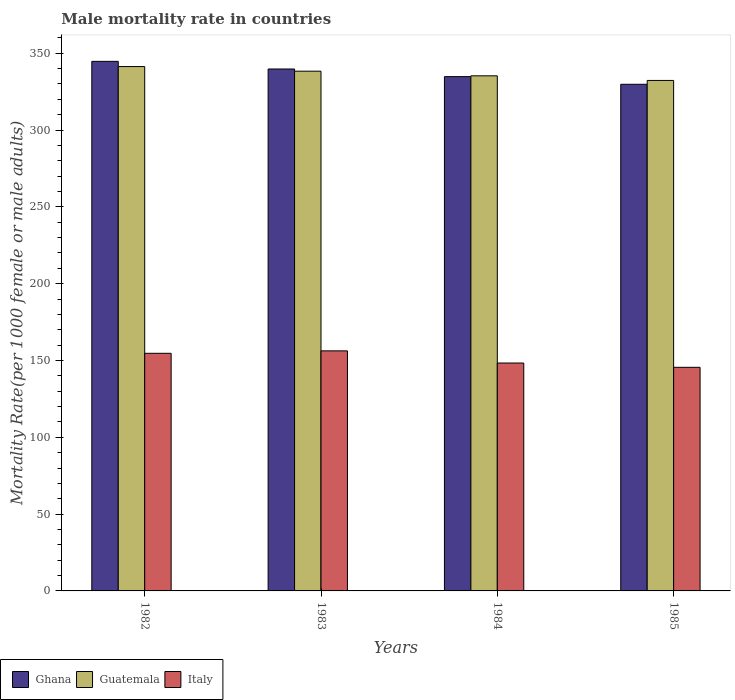Are the number of bars on each tick of the X-axis equal?
Ensure brevity in your answer.  Yes. How many bars are there on the 4th tick from the right?
Make the answer very short. 3. What is the label of the 3rd group of bars from the left?
Make the answer very short. 1984. In how many cases, is the number of bars for a given year not equal to the number of legend labels?
Your answer should be very brief. 0. What is the male mortality rate in Ghana in 1982?
Provide a short and direct response. 344.7. Across all years, what is the maximum male mortality rate in Ghana?
Provide a succinct answer. 344.7. Across all years, what is the minimum male mortality rate in Guatemala?
Provide a succinct answer. 332.27. What is the total male mortality rate in Guatemala in the graph?
Offer a very short reply. 1347.18. What is the difference between the male mortality rate in Italy in 1982 and that in 1985?
Ensure brevity in your answer.  9.12. What is the difference between the male mortality rate in Italy in 1982 and the male mortality rate in Guatemala in 1983?
Offer a terse response. -183.63. What is the average male mortality rate in Ghana per year?
Ensure brevity in your answer.  337.24. In the year 1983, what is the difference between the male mortality rate in Italy and male mortality rate in Ghana?
Give a very brief answer. -183.47. In how many years, is the male mortality rate in Italy greater than 270?
Offer a terse response. 0. What is the ratio of the male mortality rate in Italy in 1983 to that in 1985?
Give a very brief answer. 1.07. Is the difference between the male mortality rate in Italy in 1982 and 1984 greater than the difference between the male mortality rate in Ghana in 1982 and 1984?
Ensure brevity in your answer.  No. What is the difference between the highest and the second highest male mortality rate in Italy?
Your response must be concise. 1.58. What is the difference between the highest and the lowest male mortality rate in Ghana?
Give a very brief answer. 14.93. In how many years, is the male mortality rate in Ghana greater than the average male mortality rate in Ghana taken over all years?
Offer a terse response. 2. What does the 2nd bar from the left in 1985 represents?
Offer a terse response. Guatemala. What does the 1st bar from the right in 1983 represents?
Offer a terse response. Italy. Is it the case that in every year, the sum of the male mortality rate in Guatemala and male mortality rate in Ghana is greater than the male mortality rate in Italy?
Offer a terse response. Yes. How many bars are there?
Your answer should be very brief. 12. Are all the bars in the graph horizontal?
Provide a short and direct response. No. How many years are there in the graph?
Make the answer very short. 4. How many legend labels are there?
Ensure brevity in your answer.  3. How are the legend labels stacked?
Provide a short and direct response. Horizontal. What is the title of the graph?
Ensure brevity in your answer.  Male mortality rate in countries. Does "South Africa" appear as one of the legend labels in the graph?
Keep it short and to the point. No. What is the label or title of the X-axis?
Your response must be concise. Years. What is the label or title of the Y-axis?
Make the answer very short. Mortality Rate(per 1000 female or male adults). What is the Mortality Rate(per 1000 female or male adults) of Ghana in 1982?
Your answer should be very brief. 344.7. What is the Mortality Rate(per 1000 female or male adults) in Guatemala in 1982?
Provide a short and direct response. 341.32. What is the Mortality Rate(per 1000 female or male adults) in Italy in 1982?
Offer a very short reply. 154.67. What is the Mortality Rate(per 1000 female or male adults) in Ghana in 1983?
Provide a short and direct response. 339.73. What is the Mortality Rate(per 1000 female or male adults) in Guatemala in 1983?
Provide a succinct answer. 338.3. What is the Mortality Rate(per 1000 female or male adults) in Italy in 1983?
Offer a terse response. 156.25. What is the Mortality Rate(per 1000 female or male adults) of Ghana in 1984?
Ensure brevity in your answer.  334.75. What is the Mortality Rate(per 1000 female or male adults) of Guatemala in 1984?
Provide a succinct answer. 335.29. What is the Mortality Rate(per 1000 female or male adults) in Italy in 1984?
Your answer should be compact. 148.34. What is the Mortality Rate(per 1000 female or male adults) in Ghana in 1985?
Offer a very short reply. 329.77. What is the Mortality Rate(per 1000 female or male adults) of Guatemala in 1985?
Your answer should be very brief. 332.27. What is the Mortality Rate(per 1000 female or male adults) in Italy in 1985?
Provide a succinct answer. 145.55. Across all years, what is the maximum Mortality Rate(per 1000 female or male adults) of Ghana?
Your response must be concise. 344.7. Across all years, what is the maximum Mortality Rate(per 1000 female or male adults) in Guatemala?
Your answer should be very brief. 341.32. Across all years, what is the maximum Mortality Rate(per 1000 female or male adults) in Italy?
Provide a succinct answer. 156.25. Across all years, what is the minimum Mortality Rate(per 1000 female or male adults) in Ghana?
Provide a short and direct response. 329.77. Across all years, what is the minimum Mortality Rate(per 1000 female or male adults) in Guatemala?
Provide a short and direct response. 332.27. Across all years, what is the minimum Mortality Rate(per 1000 female or male adults) of Italy?
Offer a very short reply. 145.55. What is the total Mortality Rate(per 1000 female or male adults) of Ghana in the graph?
Make the answer very short. 1348.95. What is the total Mortality Rate(per 1000 female or male adults) of Guatemala in the graph?
Your answer should be very brief. 1347.18. What is the total Mortality Rate(per 1000 female or male adults) of Italy in the graph?
Give a very brief answer. 604.82. What is the difference between the Mortality Rate(per 1000 female or male adults) in Ghana in 1982 and that in 1983?
Offer a very short reply. 4.97. What is the difference between the Mortality Rate(per 1000 female or male adults) in Guatemala in 1982 and that in 1983?
Ensure brevity in your answer.  3.01. What is the difference between the Mortality Rate(per 1000 female or male adults) of Italy in 1982 and that in 1983?
Provide a short and direct response. -1.58. What is the difference between the Mortality Rate(per 1000 female or male adults) in Ghana in 1982 and that in 1984?
Make the answer very short. 9.95. What is the difference between the Mortality Rate(per 1000 female or male adults) in Guatemala in 1982 and that in 1984?
Give a very brief answer. 6.03. What is the difference between the Mortality Rate(per 1000 female or male adults) in Italy in 1982 and that in 1984?
Offer a terse response. 6.33. What is the difference between the Mortality Rate(per 1000 female or male adults) of Ghana in 1982 and that in 1985?
Your answer should be very brief. 14.93. What is the difference between the Mortality Rate(per 1000 female or male adults) in Guatemala in 1982 and that in 1985?
Make the answer very short. 9.04. What is the difference between the Mortality Rate(per 1000 female or male adults) of Italy in 1982 and that in 1985?
Offer a very short reply. 9.12. What is the difference between the Mortality Rate(per 1000 female or male adults) in Ghana in 1983 and that in 1984?
Make the answer very short. 4.97. What is the difference between the Mortality Rate(per 1000 female or male adults) in Guatemala in 1983 and that in 1984?
Your answer should be compact. 3.01. What is the difference between the Mortality Rate(per 1000 female or male adults) of Italy in 1983 and that in 1984?
Keep it short and to the point. 7.91. What is the difference between the Mortality Rate(per 1000 female or male adults) in Ghana in 1983 and that in 1985?
Your answer should be compact. 9.95. What is the difference between the Mortality Rate(per 1000 female or male adults) of Guatemala in 1983 and that in 1985?
Provide a succinct answer. 6.03. What is the difference between the Mortality Rate(per 1000 female or male adults) in Italy in 1983 and that in 1985?
Keep it short and to the point. 10.71. What is the difference between the Mortality Rate(per 1000 female or male adults) of Ghana in 1984 and that in 1985?
Provide a succinct answer. 4.97. What is the difference between the Mortality Rate(per 1000 female or male adults) in Guatemala in 1984 and that in 1985?
Offer a very short reply. 3.02. What is the difference between the Mortality Rate(per 1000 female or male adults) in Italy in 1984 and that in 1985?
Make the answer very short. 2.79. What is the difference between the Mortality Rate(per 1000 female or male adults) of Ghana in 1982 and the Mortality Rate(per 1000 female or male adults) of Guatemala in 1983?
Your answer should be very brief. 6.4. What is the difference between the Mortality Rate(per 1000 female or male adults) of Ghana in 1982 and the Mortality Rate(per 1000 female or male adults) of Italy in 1983?
Your answer should be very brief. 188.44. What is the difference between the Mortality Rate(per 1000 female or male adults) in Guatemala in 1982 and the Mortality Rate(per 1000 female or male adults) in Italy in 1983?
Provide a succinct answer. 185.06. What is the difference between the Mortality Rate(per 1000 female or male adults) in Ghana in 1982 and the Mortality Rate(per 1000 female or male adults) in Guatemala in 1984?
Provide a succinct answer. 9.41. What is the difference between the Mortality Rate(per 1000 female or male adults) in Ghana in 1982 and the Mortality Rate(per 1000 female or male adults) in Italy in 1984?
Offer a terse response. 196.36. What is the difference between the Mortality Rate(per 1000 female or male adults) of Guatemala in 1982 and the Mortality Rate(per 1000 female or male adults) of Italy in 1984?
Provide a short and direct response. 192.97. What is the difference between the Mortality Rate(per 1000 female or male adults) in Ghana in 1982 and the Mortality Rate(per 1000 female or male adults) in Guatemala in 1985?
Your answer should be very brief. 12.43. What is the difference between the Mortality Rate(per 1000 female or male adults) in Ghana in 1982 and the Mortality Rate(per 1000 female or male adults) in Italy in 1985?
Offer a terse response. 199.15. What is the difference between the Mortality Rate(per 1000 female or male adults) in Guatemala in 1982 and the Mortality Rate(per 1000 female or male adults) in Italy in 1985?
Offer a terse response. 195.77. What is the difference between the Mortality Rate(per 1000 female or male adults) of Ghana in 1983 and the Mortality Rate(per 1000 female or male adults) of Guatemala in 1984?
Offer a very short reply. 4.44. What is the difference between the Mortality Rate(per 1000 female or male adults) of Ghana in 1983 and the Mortality Rate(per 1000 female or male adults) of Italy in 1984?
Offer a terse response. 191.38. What is the difference between the Mortality Rate(per 1000 female or male adults) in Guatemala in 1983 and the Mortality Rate(per 1000 female or male adults) in Italy in 1984?
Offer a terse response. 189.96. What is the difference between the Mortality Rate(per 1000 female or male adults) in Ghana in 1983 and the Mortality Rate(per 1000 female or male adults) in Guatemala in 1985?
Keep it short and to the point. 7.45. What is the difference between the Mortality Rate(per 1000 female or male adults) in Ghana in 1983 and the Mortality Rate(per 1000 female or male adults) in Italy in 1985?
Make the answer very short. 194.18. What is the difference between the Mortality Rate(per 1000 female or male adults) of Guatemala in 1983 and the Mortality Rate(per 1000 female or male adults) of Italy in 1985?
Keep it short and to the point. 192.75. What is the difference between the Mortality Rate(per 1000 female or male adults) in Ghana in 1984 and the Mortality Rate(per 1000 female or male adults) in Guatemala in 1985?
Provide a short and direct response. 2.48. What is the difference between the Mortality Rate(per 1000 female or male adults) in Ghana in 1984 and the Mortality Rate(per 1000 female or male adults) in Italy in 1985?
Your response must be concise. 189.2. What is the difference between the Mortality Rate(per 1000 female or male adults) in Guatemala in 1984 and the Mortality Rate(per 1000 female or male adults) in Italy in 1985?
Provide a succinct answer. 189.74. What is the average Mortality Rate(per 1000 female or male adults) in Ghana per year?
Keep it short and to the point. 337.24. What is the average Mortality Rate(per 1000 female or male adults) of Guatemala per year?
Give a very brief answer. 336.79. What is the average Mortality Rate(per 1000 female or male adults) in Italy per year?
Your answer should be compact. 151.2. In the year 1982, what is the difference between the Mortality Rate(per 1000 female or male adults) of Ghana and Mortality Rate(per 1000 female or male adults) of Guatemala?
Provide a short and direct response. 3.38. In the year 1982, what is the difference between the Mortality Rate(per 1000 female or male adults) of Ghana and Mortality Rate(per 1000 female or male adults) of Italy?
Keep it short and to the point. 190.03. In the year 1982, what is the difference between the Mortality Rate(per 1000 female or male adults) of Guatemala and Mortality Rate(per 1000 female or male adults) of Italy?
Offer a terse response. 186.65. In the year 1983, what is the difference between the Mortality Rate(per 1000 female or male adults) in Ghana and Mortality Rate(per 1000 female or male adults) in Guatemala?
Provide a succinct answer. 1.42. In the year 1983, what is the difference between the Mortality Rate(per 1000 female or male adults) of Ghana and Mortality Rate(per 1000 female or male adults) of Italy?
Offer a very short reply. 183.47. In the year 1983, what is the difference between the Mortality Rate(per 1000 female or male adults) in Guatemala and Mortality Rate(per 1000 female or male adults) in Italy?
Provide a short and direct response. 182.05. In the year 1984, what is the difference between the Mortality Rate(per 1000 female or male adults) in Ghana and Mortality Rate(per 1000 female or male adults) in Guatemala?
Provide a short and direct response. -0.54. In the year 1984, what is the difference between the Mortality Rate(per 1000 female or male adults) in Ghana and Mortality Rate(per 1000 female or male adults) in Italy?
Offer a very short reply. 186.41. In the year 1984, what is the difference between the Mortality Rate(per 1000 female or male adults) of Guatemala and Mortality Rate(per 1000 female or male adults) of Italy?
Offer a terse response. 186.95. In the year 1985, what is the difference between the Mortality Rate(per 1000 female or male adults) in Ghana and Mortality Rate(per 1000 female or male adults) in Guatemala?
Keep it short and to the point. -2.5. In the year 1985, what is the difference between the Mortality Rate(per 1000 female or male adults) in Ghana and Mortality Rate(per 1000 female or male adults) in Italy?
Your answer should be very brief. 184.23. In the year 1985, what is the difference between the Mortality Rate(per 1000 female or male adults) in Guatemala and Mortality Rate(per 1000 female or male adults) in Italy?
Offer a very short reply. 186.73. What is the ratio of the Mortality Rate(per 1000 female or male adults) in Ghana in 1982 to that in 1983?
Provide a short and direct response. 1.01. What is the ratio of the Mortality Rate(per 1000 female or male adults) of Guatemala in 1982 to that in 1983?
Keep it short and to the point. 1.01. What is the ratio of the Mortality Rate(per 1000 female or male adults) of Italy in 1982 to that in 1983?
Your answer should be compact. 0.99. What is the ratio of the Mortality Rate(per 1000 female or male adults) in Ghana in 1982 to that in 1984?
Give a very brief answer. 1.03. What is the ratio of the Mortality Rate(per 1000 female or male adults) of Guatemala in 1982 to that in 1984?
Ensure brevity in your answer.  1.02. What is the ratio of the Mortality Rate(per 1000 female or male adults) in Italy in 1982 to that in 1984?
Keep it short and to the point. 1.04. What is the ratio of the Mortality Rate(per 1000 female or male adults) of Ghana in 1982 to that in 1985?
Offer a very short reply. 1.05. What is the ratio of the Mortality Rate(per 1000 female or male adults) of Guatemala in 1982 to that in 1985?
Offer a terse response. 1.03. What is the ratio of the Mortality Rate(per 1000 female or male adults) of Italy in 1982 to that in 1985?
Provide a succinct answer. 1.06. What is the ratio of the Mortality Rate(per 1000 female or male adults) in Ghana in 1983 to that in 1984?
Offer a terse response. 1.01. What is the ratio of the Mortality Rate(per 1000 female or male adults) in Guatemala in 1983 to that in 1984?
Your answer should be very brief. 1.01. What is the ratio of the Mortality Rate(per 1000 female or male adults) in Italy in 1983 to that in 1984?
Offer a terse response. 1.05. What is the ratio of the Mortality Rate(per 1000 female or male adults) of Ghana in 1983 to that in 1985?
Offer a very short reply. 1.03. What is the ratio of the Mortality Rate(per 1000 female or male adults) of Guatemala in 1983 to that in 1985?
Ensure brevity in your answer.  1.02. What is the ratio of the Mortality Rate(per 1000 female or male adults) in Italy in 1983 to that in 1985?
Offer a very short reply. 1.07. What is the ratio of the Mortality Rate(per 1000 female or male adults) in Ghana in 1984 to that in 1985?
Make the answer very short. 1.02. What is the ratio of the Mortality Rate(per 1000 female or male adults) of Guatemala in 1984 to that in 1985?
Offer a very short reply. 1.01. What is the ratio of the Mortality Rate(per 1000 female or male adults) in Italy in 1984 to that in 1985?
Provide a succinct answer. 1.02. What is the difference between the highest and the second highest Mortality Rate(per 1000 female or male adults) of Ghana?
Keep it short and to the point. 4.97. What is the difference between the highest and the second highest Mortality Rate(per 1000 female or male adults) of Guatemala?
Keep it short and to the point. 3.01. What is the difference between the highest and the second highest Mortality Rate(per 1000 female or male adults) of Italy?
Your answer should be very brief. 1.58. What is the difference between the highest and the lowest Mortality Rate(per 1000 female or male adults) of Ghana?
Provide a short and direct response. 14.93. What is the difference between the highest and the lowest Mortality Rate(per 1000 female or male adults) in Guatemala?
Offer a very short reply. 9.04. What is the difference between the highest and the lowest Mortality Rate(per 1000 female or male adults) of Italy?
Provide a succinct answer. 10.71. 